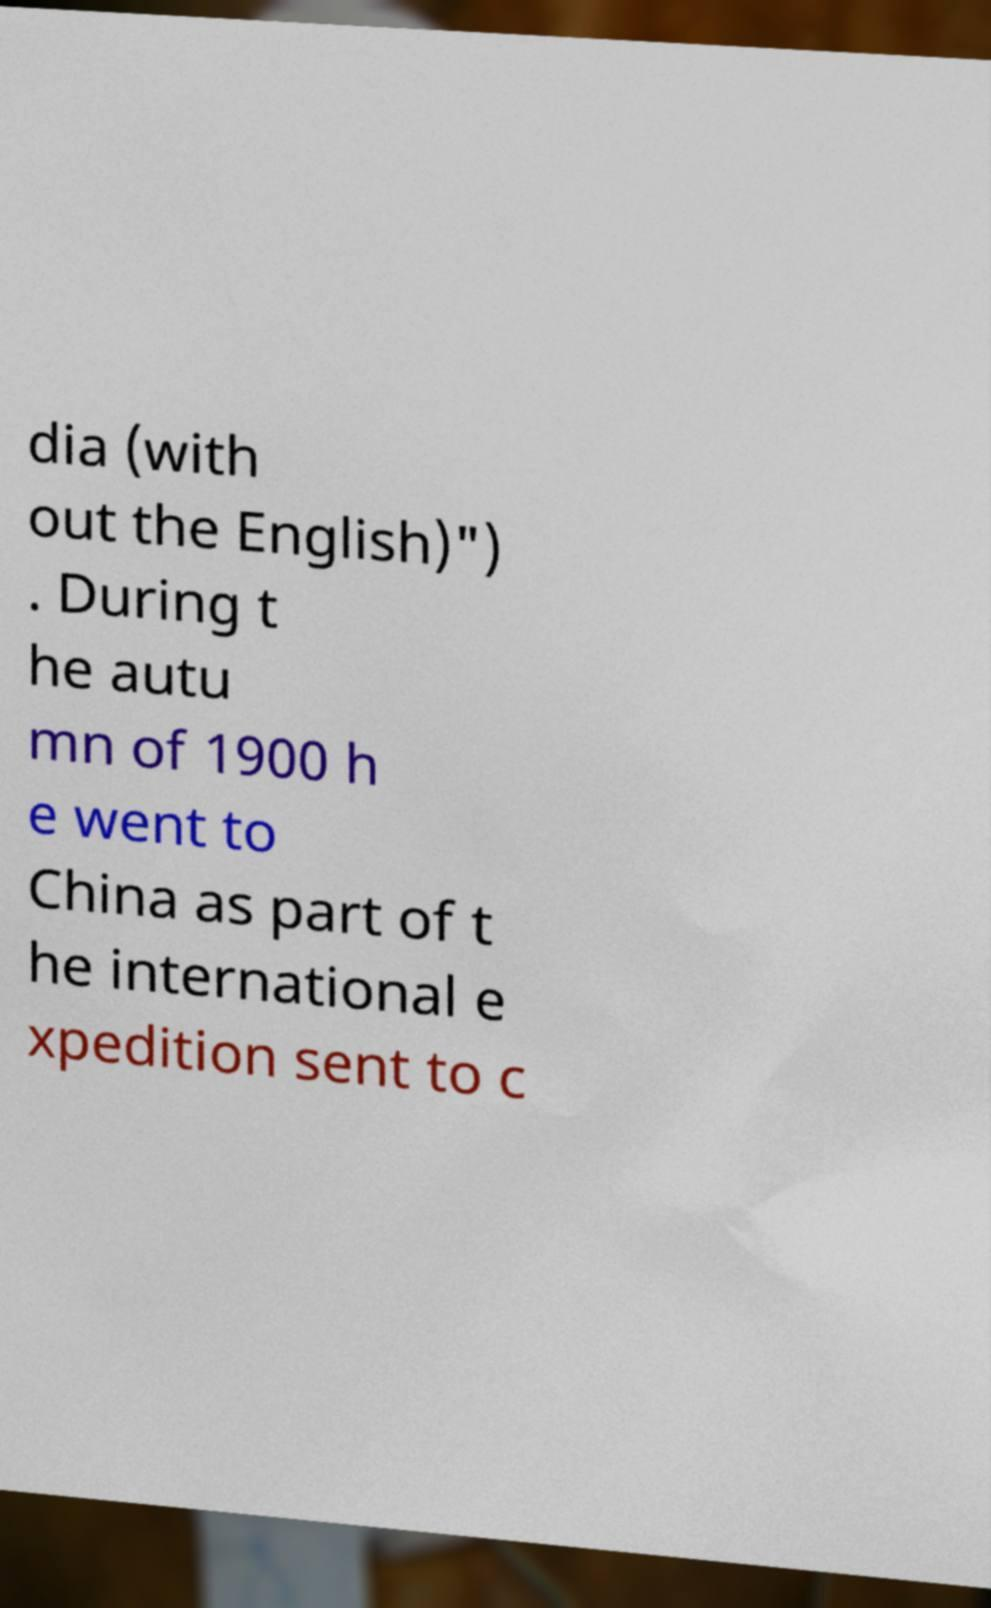What messages or text are displayed in this image? I need them in a readable, typed format. dia (with out the English)") . During t he autu mn of 1900 h e went to China as part of t he international e xpedition sent to c 